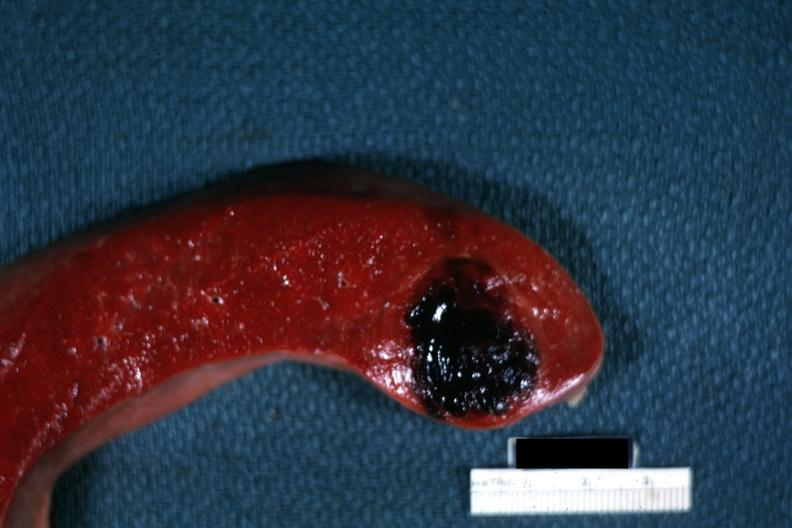what is present?
Answer the question using a single word or phrase. Hemangioma 